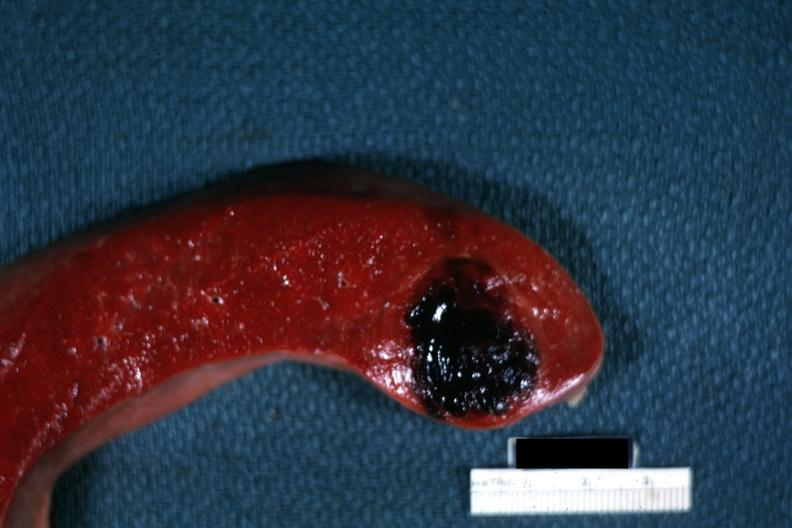what is present?
Answer the question using a single word or phrase. Hemangioma 